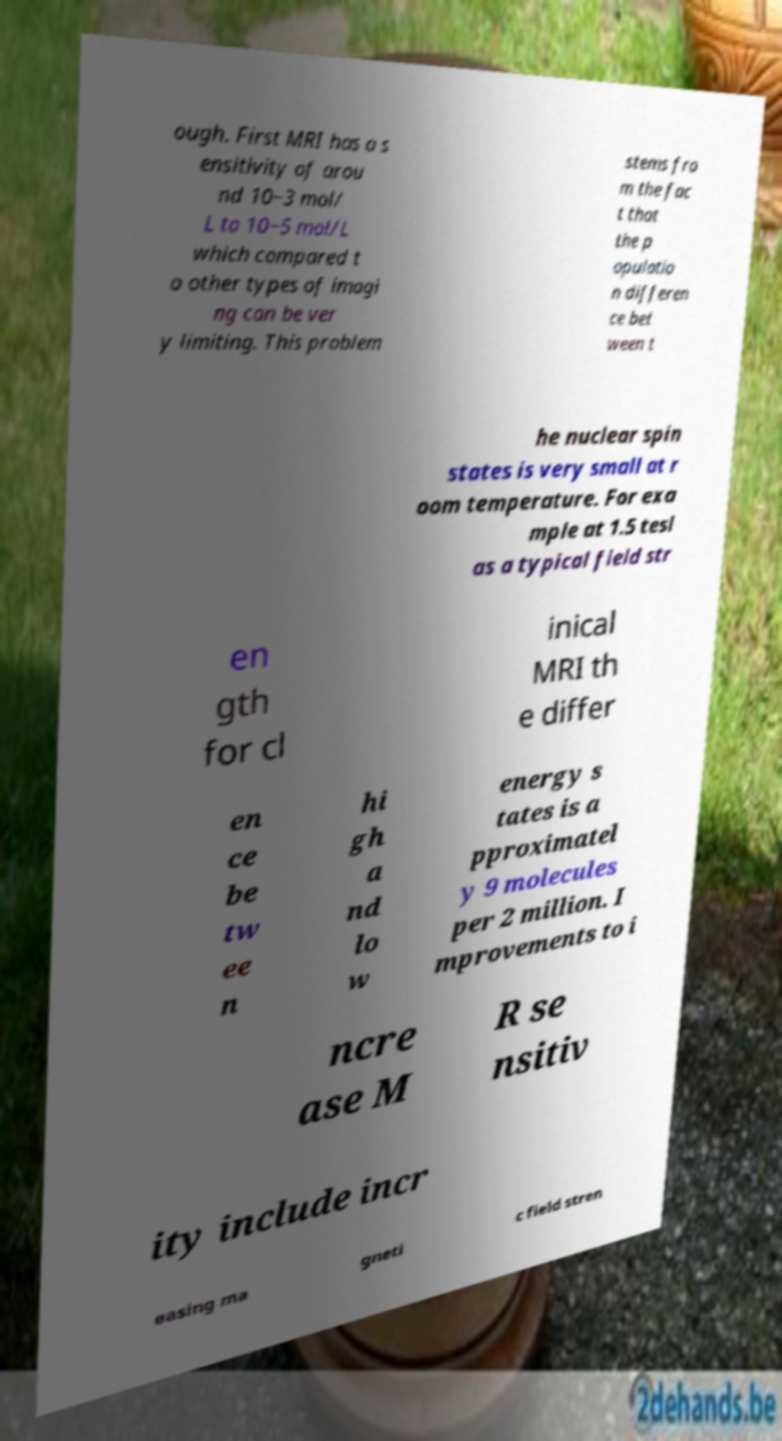What messages or text are displayed in this image? I need them in a readable, typed format. ough. First MRI has a s ensitivity of arou nd 10−3 mol/ L to 10−5 mol/L which compared t o other types of imagi ng can be ver y limiting. This problem stems fro m the fac t that the p opulatio n differen ce bet ween t he nuclear spin states is very small at r oom temperature. For exa mple at 1.5 tesl as a typical field str en gth for cl inical MRI th e differ en ce be tw ee n hi gh a nd lo w energy s tates is a pproximatel y 9 molecules per 2 million. I mprovements to i ncre ase M R se nsitiv ity include incr easing ma gneti c field stren 